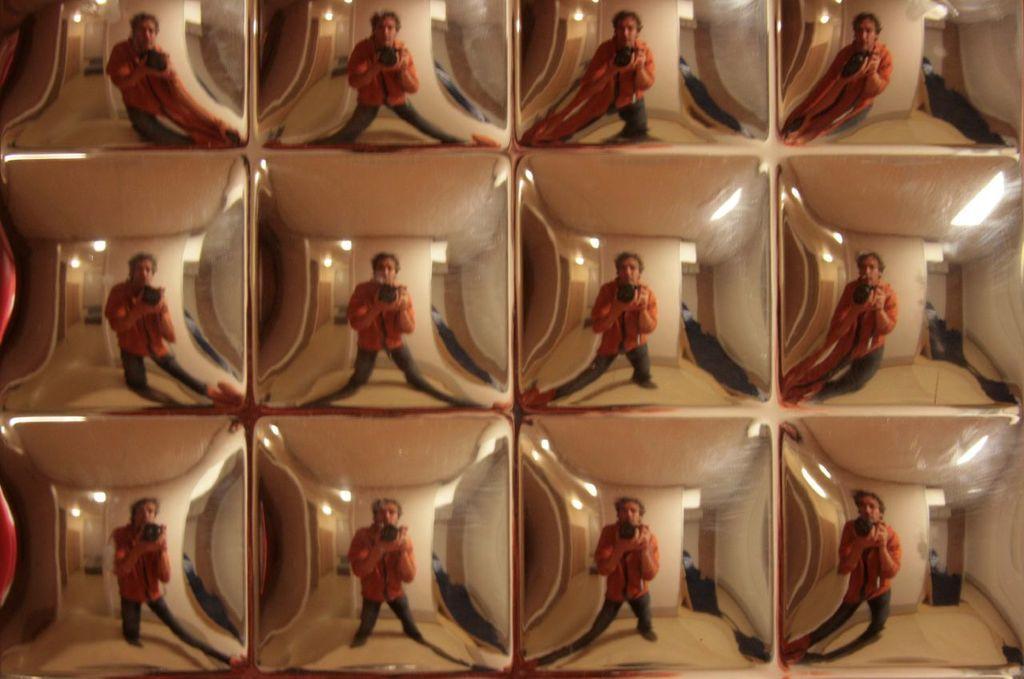How would you summarize this image in a sentence or two? In this image we can see the reflection of a person, a camera and interior of the house on some object. 